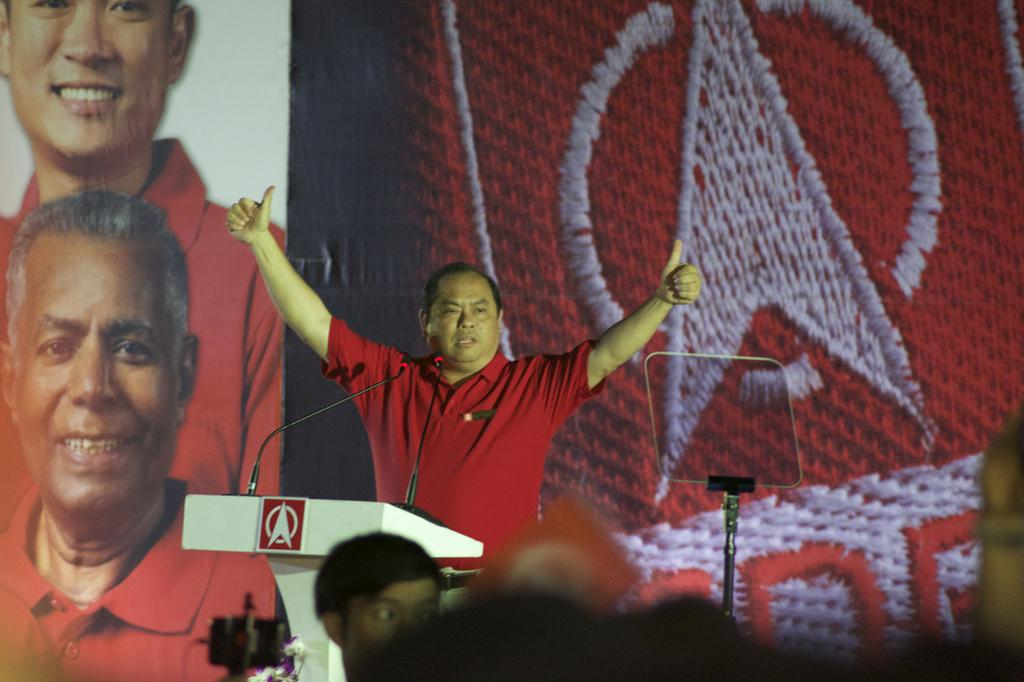What is the person at the front of the image doing? There is a person standing at the lectern in the image. What can be seen on the lectern? Mics are placed on the lectern. What is visible in the background of the image? There is an advertisement in the background. Can you describe the presence of another person in the image? There is a person in the background. What type of animals can be seen in the zoo in the image? There is no zoo present in the image; it features a person standing at a lectern with mics and an advertisement in the background. How does the oven in the image affect the temperature of the room? There is no oven present in the image. 